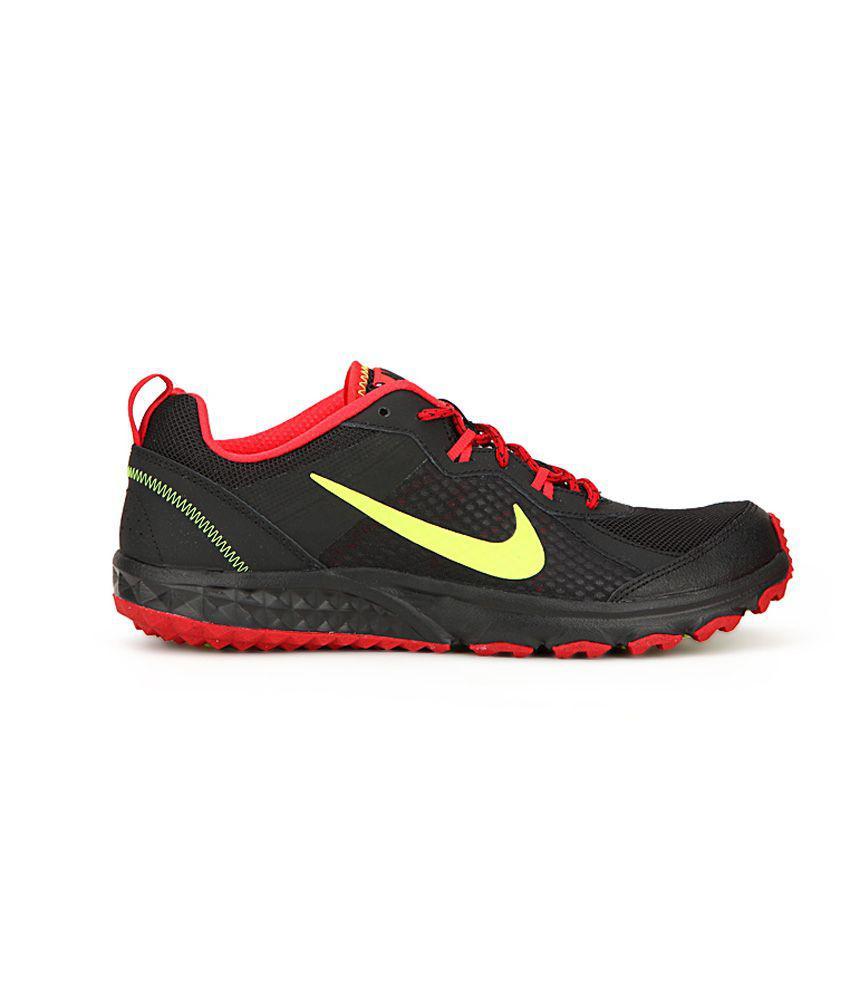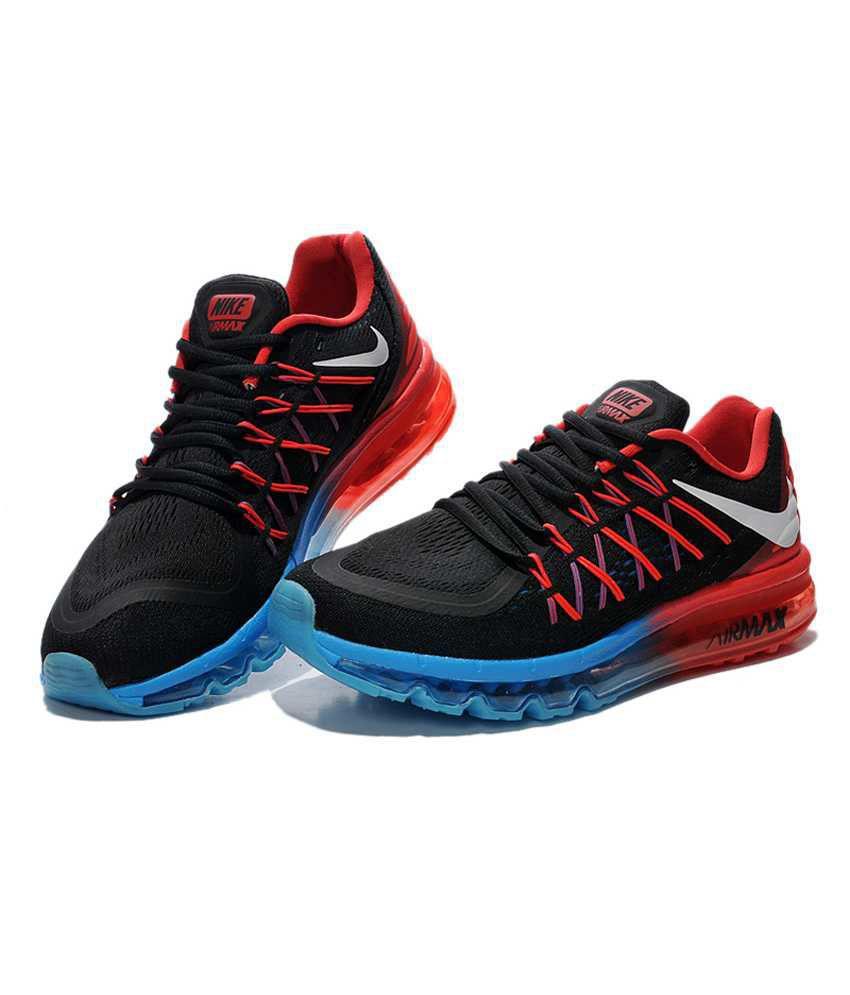The first image is the image on the left, the second image is the image on the right. Given the left and right images, does the statement "One image shows at least one black-laced shoe that is black with red and blue trim." hold true? Answer yes or no. Yes. The first image is the image on the left, the second image is the image on the right. Given the left and right images, does the statement "A shoe facing left has a lime green ribbon shape on it in one image." hold true? Answer yes or no. No. 